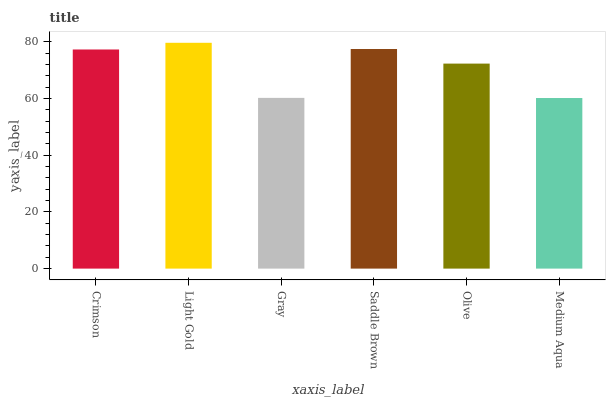Is Medium Aqua the minimum?
Answer yes or no. Yes. Is Light Gold the maximum?
Answer yes or no. Yes. Is Gray the minimum?
Answer yes or no. No. Is Gray the maximum?
Answer yes or no. No. Is Light Gold greater than Gray?
Answer yes or no. Yes. Is Gray less than Light Gold?
Answer yes or no. Yes. Is Gray greater than Light Gold?
Answer yes or no. No. Is Light Gold less than Gray?
Answer yes or no. No. Is Crimson the high median?
Answer yes or no. Yes. Is Olive the low median?
Answer yes or no. Yes. Is Gray the high median?
Answer yes or no. No. Is Medium Aqua the low median?
Answer yes or no. No. 